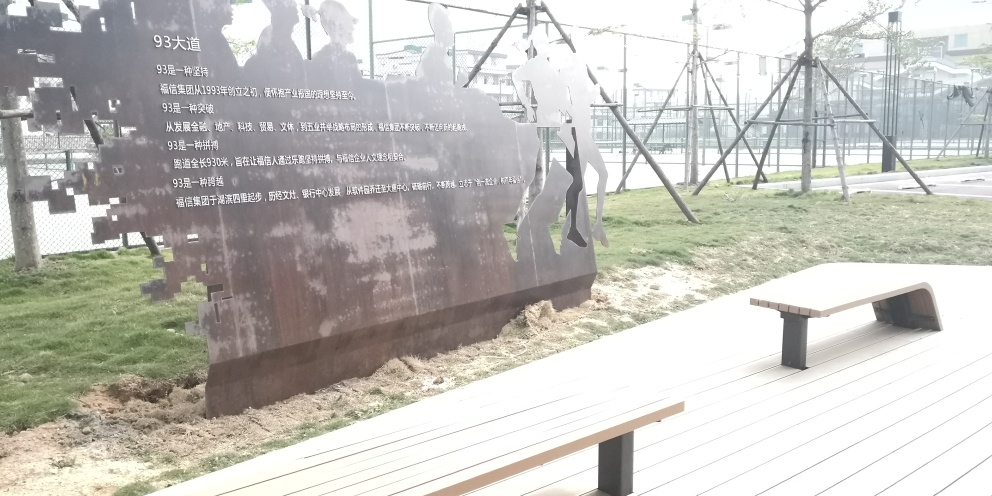Why does the image have a bench in the foreground? The bench in the foreground adds a functional element to the space, inviting viewers to sit and reflect on the art piece. It also helps to create a space that feels more accessible and interactive, offering a place to rest, observe, and perhaps contemplate the meaning behind the silhouettes and the overall setting. 